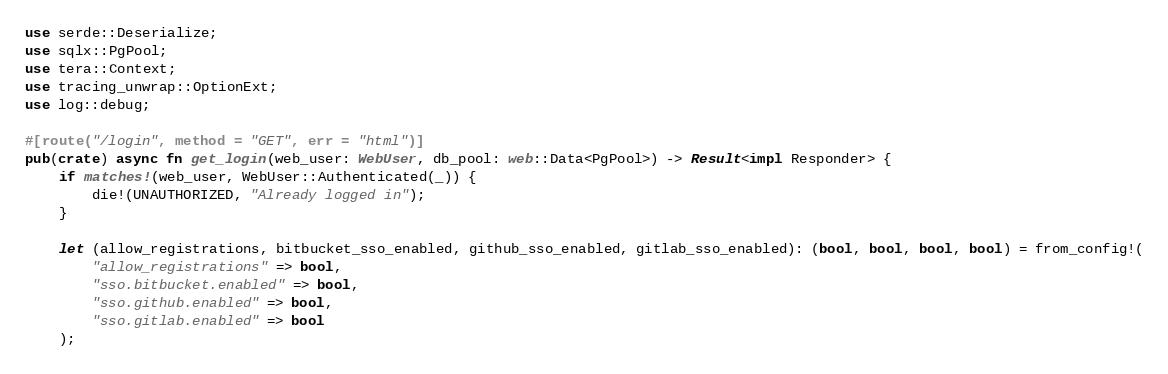<code> <loc_0><loc_0><loc_500><loc_500><_Rust_>use serde::Deserialize;
use sqlx::PgPool;
use tera::Context;
use tracing_unwrap::OptionExt;
use log::debug;

#[route("/login", method = "GET", err = "html")]
pub(crate) async fn get_login(web_user: WebUser, db_pool: web::Data<PgPool>) -> Result<impl Responder> {
    if matches!(web_user, WebUser::Authenticated(_)) {
        die!(UNAUTHORIZED, "Already logged in");
    }

    let (allow_registrations, bitbucket_sso_enabled, github_sso_enabled, gitlab_sso_enabled): (bool, bool, bool, bool) = from_config!(
        "allow_registrations" => bool,
        "sso.bitbucket.enabled" => bool,
        "sso.github.enabled" => bool,
        "sso.gitlab.enabled" => bool
    );
</code> 